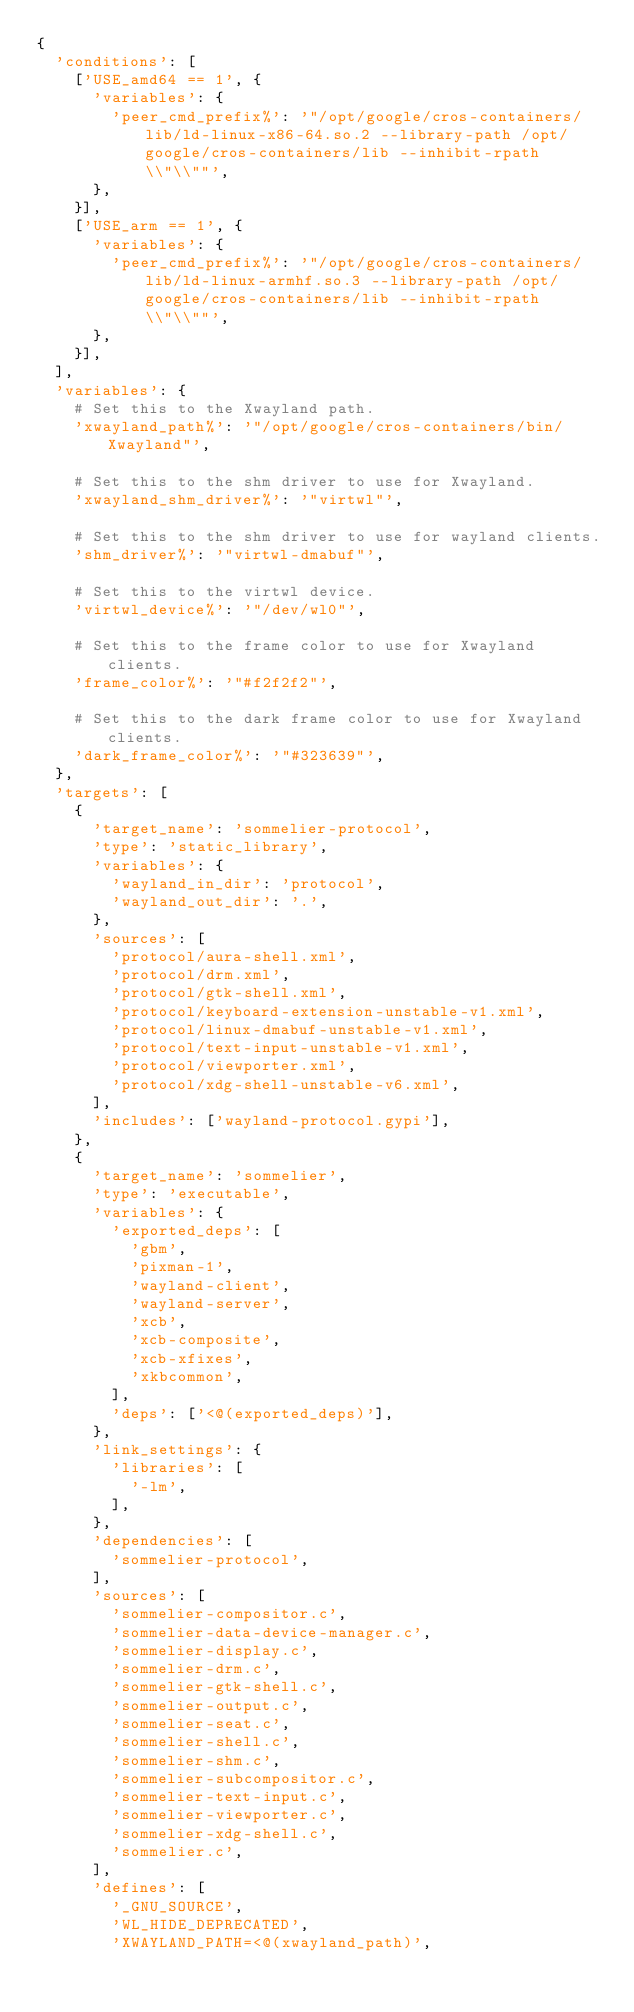<code> <loc_0><loc_0><loc_500><loc_500><_Python_>{
  'conditions': [
    ['USE_amd64 == 1', {
      'variables': {
        'peer_cmd_prefix%': '"/opt/google/cros-containers/lib/ld-linux-x86-64.so.2 --library-path /opt/google/cros-containers/lib --inhibit-rpath \\"\\""',
      },
    }],
    ['USE_arm == 1', {
      'variables': {
        'peer_cmd_prefix%': '"/opt/google/cros-containers/lib/ld-linux-armhf.so.3 --library-path /opt/google/cros-containers/lib --inhibit-rpath \\"\\""',
      },
    }],
  ],
  'variables': {
    # Set this to the Xwayland path.
    'xwayland_path%': '"/opt/google/cros-containers/bin/Xwayland"',

    # Set this to the shm driver to use for Xwayland.
    'xwayland_shm_driver%': '"virtwl"',

    # Set this to the shm driver to use for wayland clients.
    'shm_driver%': '"virtwl-dmabuf"',

    # Set this to the virtwl device.
    'virtwl_device%': '"/dev/wl0"',

    # Set this to the frame color to use for Xwayland clients.
    'frame_color%': '"#f2f2f2"',

    # Set this to the dark frame color to use for Xwayland clients.
    'dark_frame_color%': '"#323639"',
  },
  'targets': [
    {
      'target_name': 'sommelier-protocol',
      'type': 'static_library',
      'variables': {
        'wayland_in_dir': 'protocol',
        'wayland_out_dir': '.',
      },
      'sources': [
        'protocol/aura-shell.xml',
        'protocol/drm.xml',
        'protocol/gtk-shell.xml',
        'protocol/keyboard-extension-unstable-v1.xml',
        'protocol/linux-dmabuf-unstable-v1.xml',
        'protocol/text-input-unstable-v1.xml',
        'protocol/viewporter.xml',
        'protocol/xdg-shell-unstable-v6.xml',
      ],
      'includes': ['wayland-protocol.gypi'],
    },
    {
      'target_name': 'sommelier',
      'type': 'executable',
      'variables': {
        'exported_deps': [
          'gbm',
          'pixman-1',
          'wayland-client',
          'wayland-server',
          'xcb',
          'xcb-composite',
          'xcb-xfixes',
          'xkbcommon',
        ],
        'deps': ['<@(exported_deps)'],
      },
      'link_settings': {
        'libraries': [
          '-lm',
        ],
      },
      'dependencies': [
        'sommelier-protocol',
      ],
      'sources': [
        'sommelier-compositor.c',
        'sommelier-data-device-manager.c',
        'sommelier-display.c',
        'sommelier-drm.c',
        'sommelier-gtk-shell.c',
        'sommelier-output.c',
        'sommelier-seat.c',
        'sommelier-shell.c',
        'sommelier-shm.c',
        'sommelier-subcompositor.c',
        'sommelier-text-input.c',
        'sommelier-viewporter.c',
        'sommelier-xdg-shell.c',
        'sommelier.c',
      ],
      'defines': [
        '_GNU_SOURCE',
        'WL_HIDE_DEPRECATED',
        'XWAYLAND_PATH=<@(xwayland_path)',</code> 